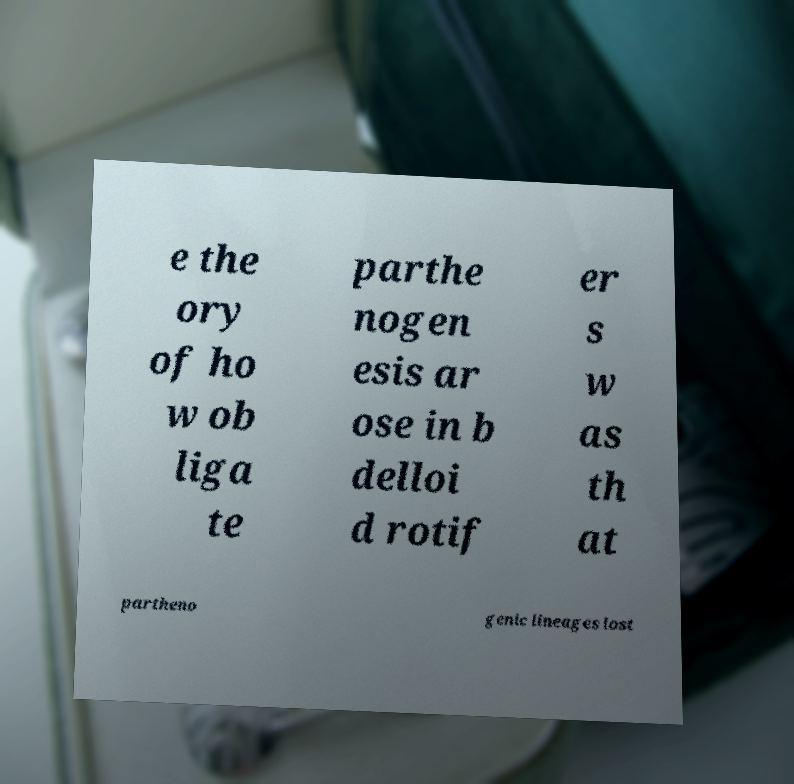Could you assist in decoding the text presented in this image and type it out clearly? e the ory of ho w ob liga te parthe nogen esis ar ose in b delloi d rotif er s w as th at partheno genic lineages lost 